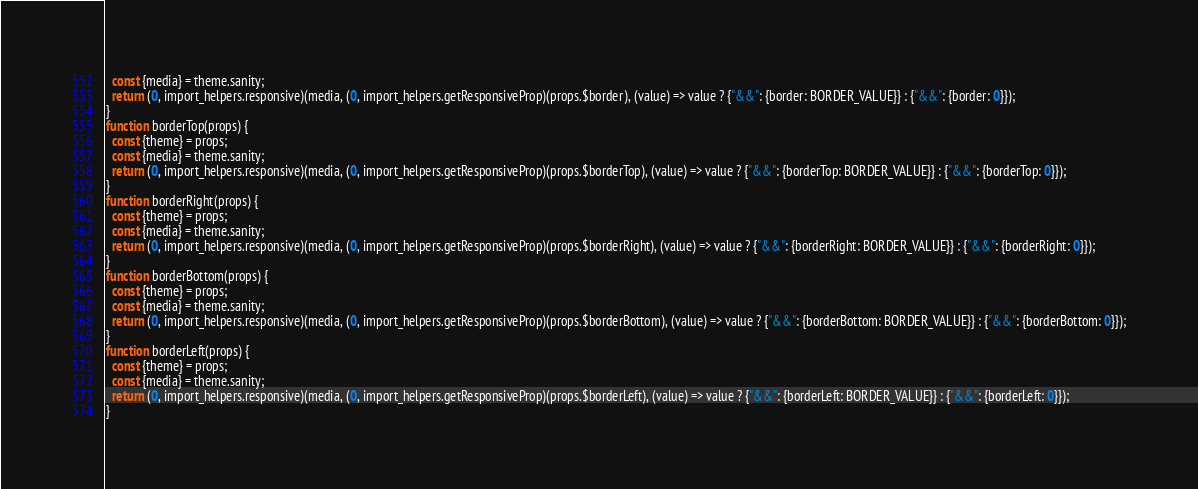Convert code to text. <code><loc_0><loc_0><loc_500><loc_500><_JavaScript_>  const {media} = theme.sanity;
  return (0, import_helpers.responsive)(media, (0, import_helpers.getResponsiveProp)(props.$border), (value) => value ? {"&&": {border: BORDER_VALUE}} : {"&&": {border: 0}});
}
function borderTop(props) {
  const {theme} = props;
  const {media} = theme.sanity;
  return (0, import_helpers.responsive)(media, (0, import_helpers.getResponsiveProp)(props.$borderTop), (value) => value ? {"&&": {borderTop: BORDER_VALUE}} : {"&&": {borderTop: 0}});
}
function borderRight(props) {
  const {theme} = props;
  const {media} = theme.sanity;
  return (0, import_helpers.responsive)(media, (0, import_helpers.getResponsiveProp)(props.$borderRight), (value) => value ? {"&&": {borderRight: BORDER_VALUE}} : {"&&": {borderRight: 0}});
}
function borderBottom(props) {
  const {theme} = props;
  const {media} = theme.sanity;
  return (0, import_helpers.responsive)(media, (0, import_helpers.getResponsiveProp)(props.$borderBottom), (value) => value ? {"&&": {borderBottom: BORDER_VALUE}} : {"&&": {borderBottom: 0}});
}
function borderLeft(props) {
  const {theme} = props;
  const {media} = theme.sanity;
  return (0, import_helpers.responsive)(media, (0, import_helpers.getResponsiveProp)(props.$borderLeft), (value) => value ? {"&&": {borderLeft: BORDER_VALUE}} : {"&&": {borderLeft: 0}});
}
</code> 